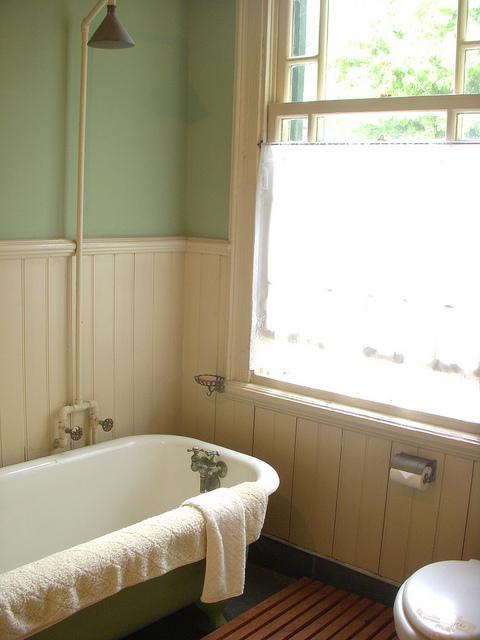How many windows are in the photo?
Concise answer only. 1. What kind of bathtub is this?
Give a very brief answer. Claw foot. How many people fit in the tub?
Write a very short answer. 1. How many towels are shown?
Be succinct. 2. Is there a tree in this picture?
Short answer required. Yes. 